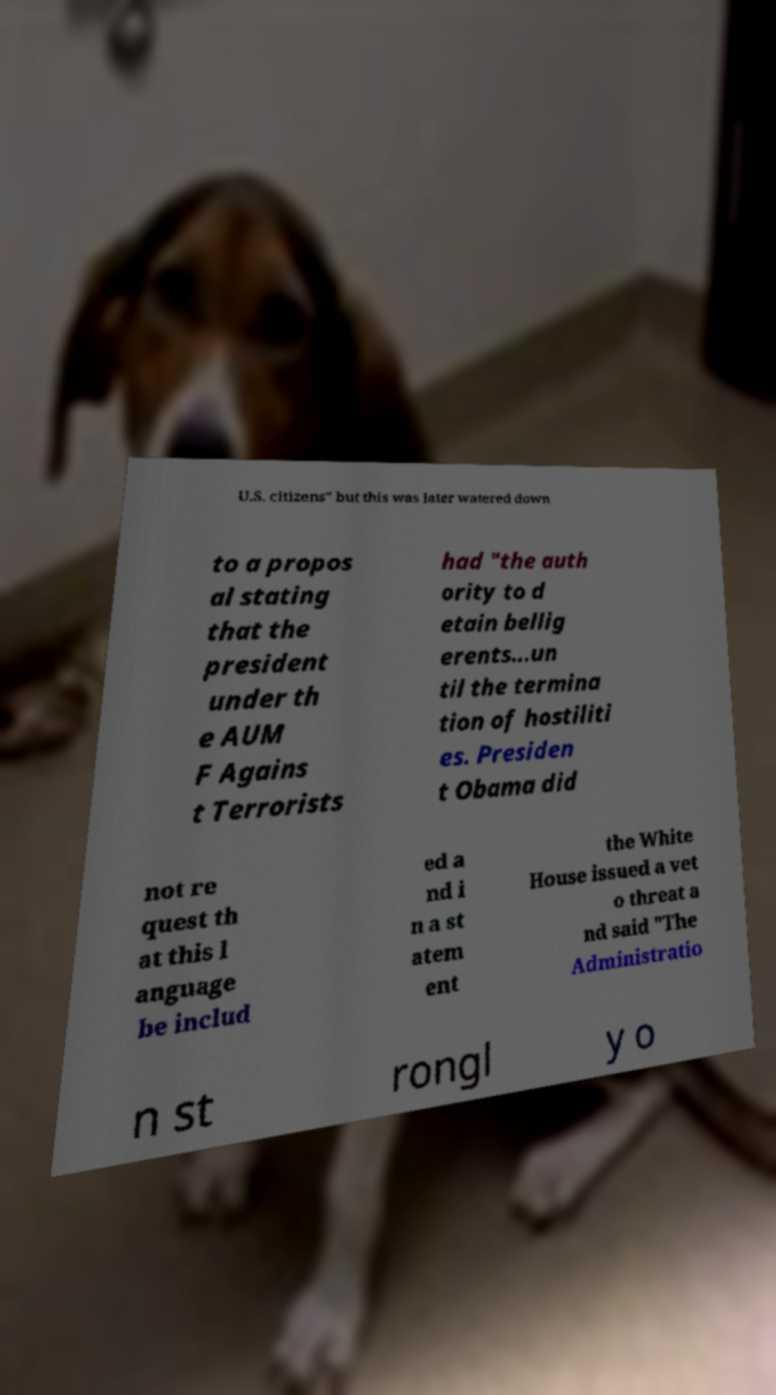Could you assist in decoding the text presented in this image and type it out clearly? U.S. citizens" but this was later watered down to a propos al stating that the president under th e AUM F Agains t Terrorists had "the auth ority to d etain bellig erents...un til the termina tion of hostiliti es. Presiden t Obama did not re quest th at this l anguage be includ ed a nd i n a st atem ent the White House issued a vet o threat a nd said "The Administratio n st rongl y o 